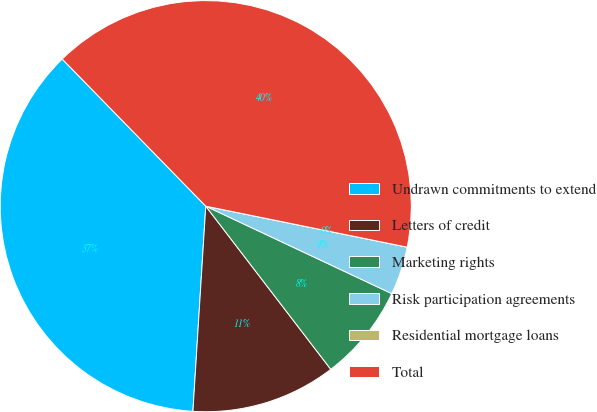Convert chart to OTSL. <chart><loc_0><loc_0><loc_500><loc_500><pie_chart><fcel>Undrawn commitments to extend<fcel>Letters of credit<fcel>Marketing rights<fcel>Risk participation agreements<fcel>Residential mortgage loans<fcel>Total<nl><fcel>36.7%<fcel>11.4%<fcel>7.6%<fcel>3.8%<fcel>0.0%<fcel>40.5%<nl></chart> 